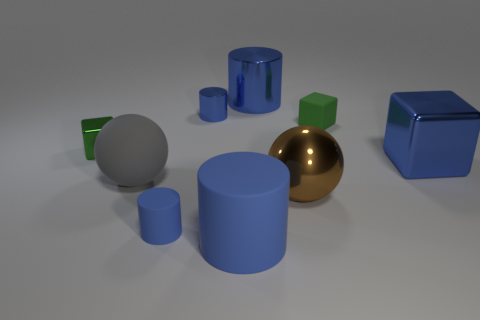There is a green object that is made of the same material as the big blue cube; what shape is it?
Keep it short and to the point. Cube. Is there anything else that has the same shape as the green metallic thing?
Make the answer very short. Yes. Is the green object to the left of the rubber ball made of the same material as the large gray sphere?
Make the answer very short. No. There is a blue thing right of the small green matte cube; what is it made of?
Your answer should be compact. Metal. What is the size of the green object in front of the small matte object behind the brown ball?
Offer a very short reply. Small. What number of matte cubes have the same size as the brown ball?
Provide a succinct answer. 0. There is a big metallic thing that is on the right side of the big brown object; does it have the same color as the big cylinder that is in front of the brown sphere?
Provide a succinct answer. Yes. Are there any brown metal spheres behind the big brown shiny ball?
Offer a terse response. No. What is the color of the matte object that is behind the small rubber cylinder and to the left of the green rubber object?
Ensure brevity in your answer.  Gray. Is there a rubber sphere of the same color as the big metal cylinder?
Ensure brevity in your answer.  No. 